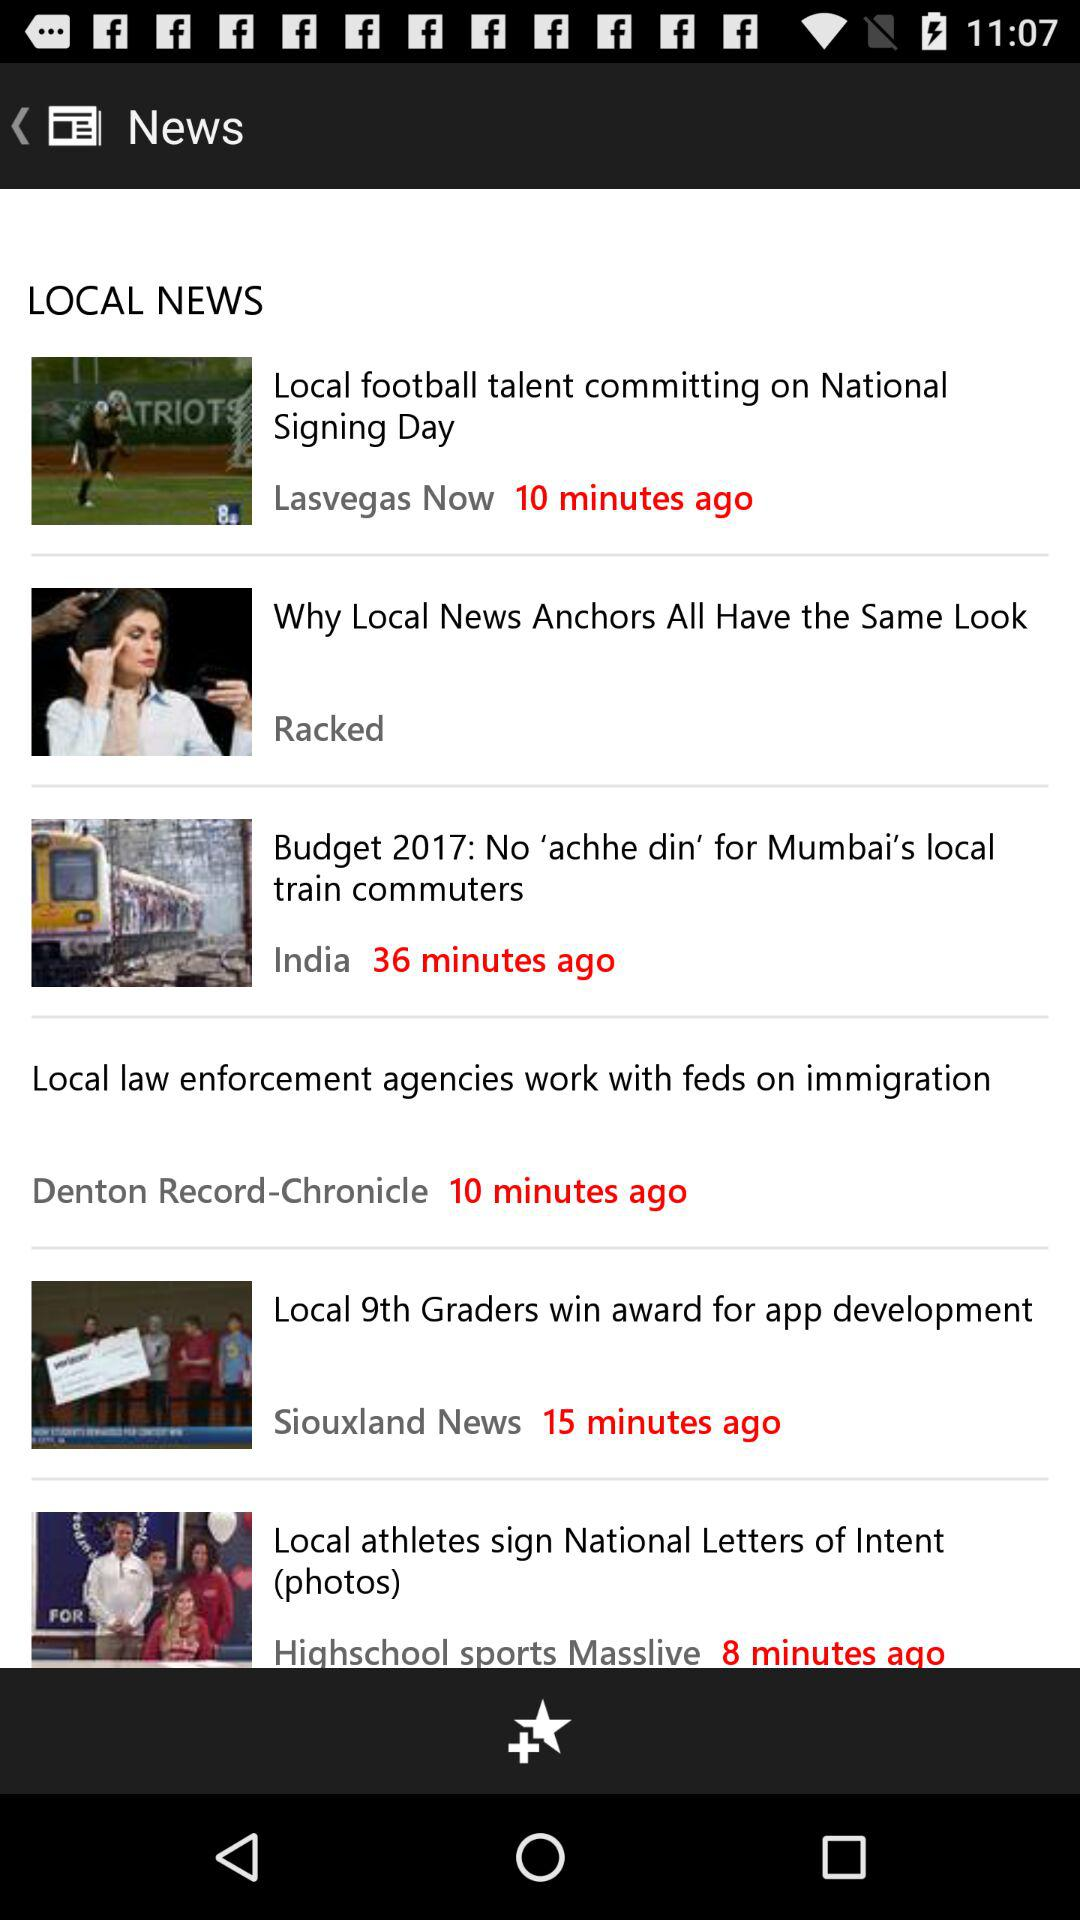How many minutes ago the national signing day news was updated? The news was updated 10 minutes ago. 